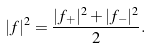Convert formula to latex. <formula><loc_0><loc_0><loc_500><loc_500>| f | ^ { 2 } = \frac { | f _ { + } | ^ { 2 } + | f _ { - } | ^ { 2 } } { 2 } .</formula> 